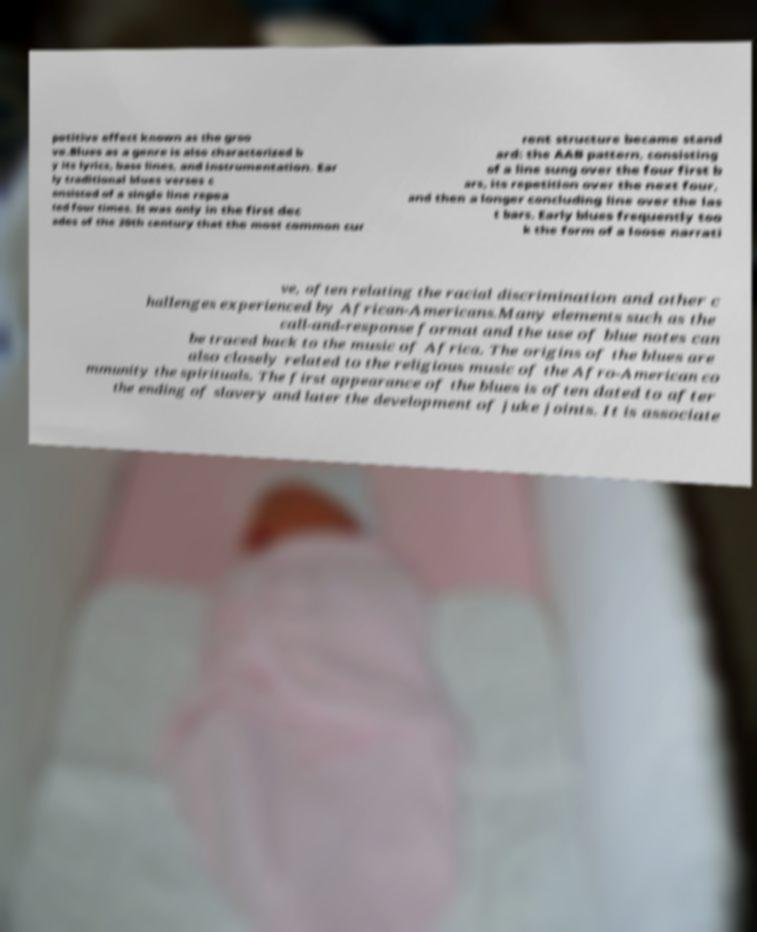Can you accurately transcribe the text from the provided image for me? petitive effect known as the groo ve.Blues as a genre is also characterized b y its lyrics, bass lines, and instrumentation. Ear ly traditional blues verses c onsisted of a single line repea ted four times. It was only in the first dec ades of the 20th century that the most common cur rent structure became stand ard: the AAB pattern, consisting of a line sung over the four first b ars, its repetition over the next four, and then a longer concluding line over the las t bars. Early blues frequently too k the form of a loose narrati ve, often relating the racial discrimination and other c hallenges experienced by African-Americans.Many elements such as the call-and-response format and the use of blue notes can be traced back to the music of Africa. The origins of the blues are also closely related to the religious music of the Afro-American co mmunity the spirituals. The first appearance of the blues is often dated to after the ending of slavery and later the development of juke joints. It is associate 